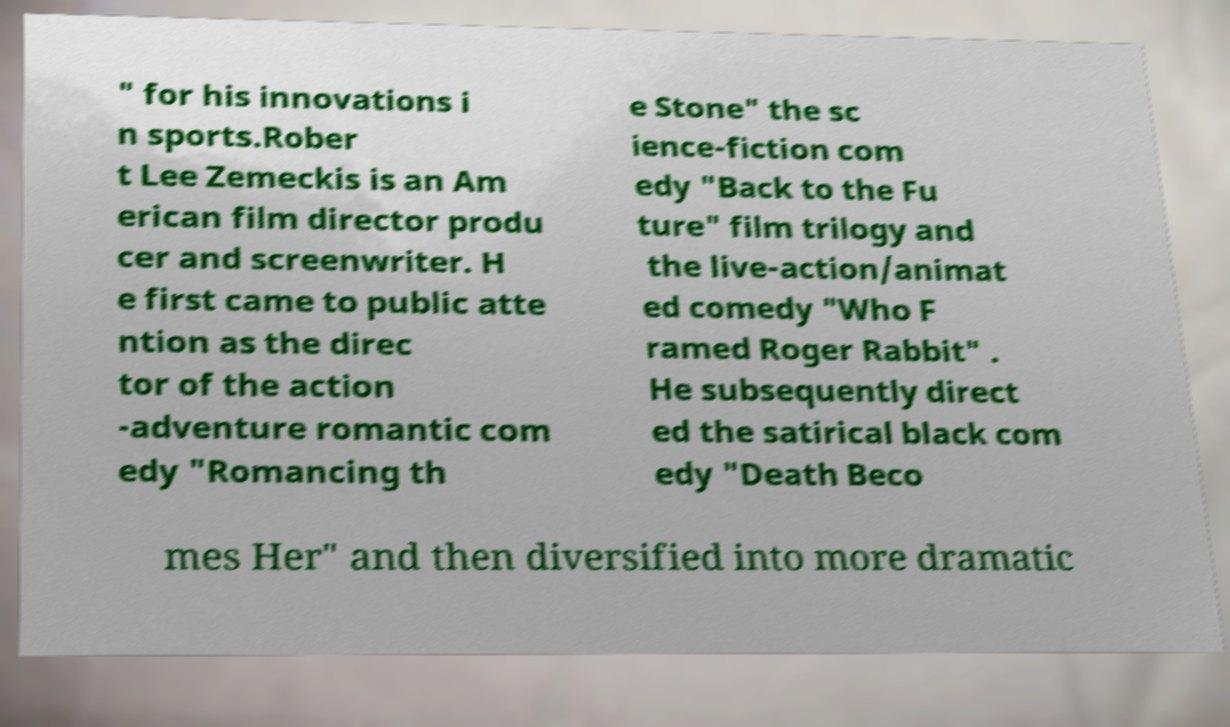Can you read and provide the text displayed in the image?This photo seems to have some interesting text. Can you extract and type it out for me? " for his innovations i n sports.Rober t Lee Zemeckis is an Am erican film director produ cer and screenwriter. H e first came to public atte ntion as the direc tor of the action -adventure romantic com edy "Romancing th e Stone" the sc ience-fiction com edy "Back to the Fu ture" film trilogy and the live-action/animat ed comedy "Who F ramed Roger Rabbit" . He subsequently direct ed the satirical black com edy "Death Beco mes Her" and then diversified into more dramatic 